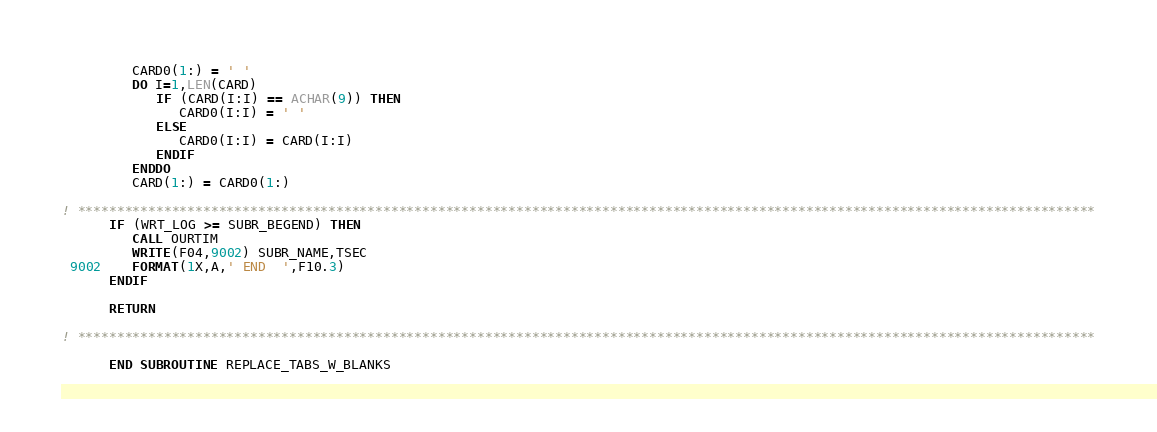<code> <loc_0><loc_0><loc_500><loc_500><_FORTRAN_>
         CARD0(1:) = ' '
         DO I=1,LEN(CARD)
            IF (CARD(I:I) == ACHAR(9)) THEN
               CARD0(I:I) = ' '
            ELSE
               CARD0(I:I) = CARD(I:I)
            ENDIF
         ENDDO
         CARD(1:) = CARD0(1:)

! **********************************************************************************************************************************
      IF (WRT_LOG >= SUBR_BEGEND) THEN
         CALL OURTIM
         WRITE(F04,9002) SUBR_NAME,TSEC
 9002    FORMAT(1X,A,' END  ',F10.3)
      ENDIF

      RETURN

! **********************************************************************************************************************************

      END SUBROUTINE REPLACE_TABS_W_BLANKS

</code> 